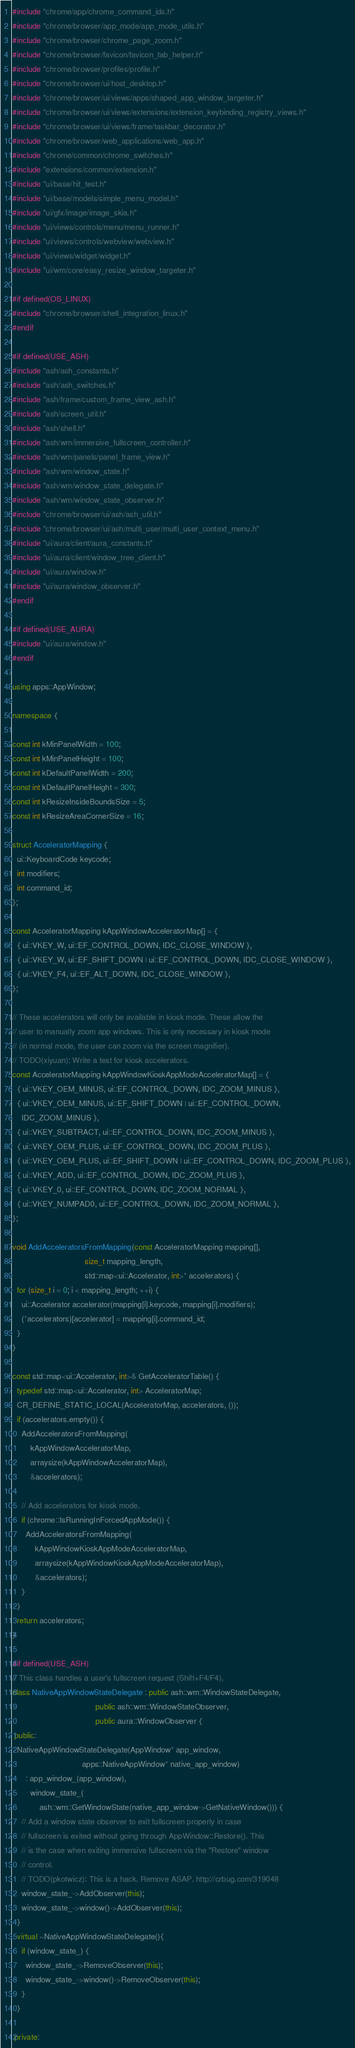Convert code to text. <code><loc_0><loc_0><loc_500><loc_500><_C++_>#include "chrome/app/chrome_command_ids.h"
#include "chrome/browser/app_mode/app_mode_utils.h"
#include "chrome/browser/chrome_page_zoom.h"
#include "chrome/browser/favicon/favicon_tab_helper.h"
#include "chrome/browser/profiles/profile.h"
#include "chrome/browser/ui/host_desktop.h"
#include "chrome/browser/ui/views/apps/shaped_app_window_targeter.h"
#include "chrome/browser/ui/views/extensions/extension_keybinding_registry_views.h"
#include "chrome/browser/ui/views/frame/taskbar_decorator.h"
#include "chrome/browser/web_applications/web_app.h"
#include "chrome/common/chrome_switches.h"
#include "extensions/common/extension.h"
#include "ui/base/hit_test.h"
#include "ui/base/models/simple_menu_model.h"
#include "ui/gfx/image/image_skia.h"
#include "ui/views/controls/menu/menu_runner.h"
#include "ui/views/controls/webview/webview.h"
#include "ui/views/widget/widget.h"
#include "ui/wm/core/easy_resize_window_targeter.h"

#if defined(OS_LINUX)
#include "chrome/browser/shell_integration_linux.h"
#endif

#if defined(USE_ASH)
#include "ash/ash_constants.h"
#include "ash/ash_switches.h"
#include "ash/frame/custom_frame_view_ash.h"
#include "ash/screen_util.h"
#include "ash/shell.h"
#include "ash/wm/immersive_fullscreen_controller.h"
#include "ash/wm/panels/panel_frame_view.h"
#include "ash/wm/window_state.h"
#include "ash/wm/window_state_delegate.h"
#include "ash/wm/window_state_observer.h"
#include "chrome/browser/ui/ash/ash_util.h"
#include "chrome/browser/ui/ash/multi_user/multi_user_context_menu.h"
#include "ui/aura/client/aura_constants.h"
#include "ui/aura/client/window_tree_client.h"
#include "ui/aura/window.h"
#include "ui/aura/window_observer.h"
#endif

#if defined(USE_AURA)
#include "ui/aura/window.h"
#endif

using apps::AppWindow;

namespace {

const int kMinPanelWidth = 100;
const int kMinPanelHeight = 100;
const int kDefaultPanelWidth = 200;
const int kDefaultPanelHeight = 300;
const int kResizeInsideBoundsSize = 5;
const int kResizeAreaCornerSize = 16;

struct AcceleratorMapping {
  ui::KeyboardCode keycode;
  int modifiers;
  int command_id;
};

const AcceleratorMapping kAppWindowAcceleratorMap[] = {
  { ui::VKEY_W, ui::EF_CONTROL_DOWN, IDC_CLOSE_WINDOW },
  { ui::VKEY_W, ui::EF_SHIFT_DOWN | ui::EF_CONTROL_DOWN, IDC_CLOSE_WINDOW },
  { ui::VKEY_F4, ui::EF_ALT_DOWN, IDC_CLOSE_WINDOW },
};

// These accelerators will only be available in kiosk mode. These allow the
// user to manually zoom app windows. This is only necessary in kiosk mode
// (in normal mode, the user can zoom via the screen magnifier).
// TODO(xiyuan): Write a test for kiosk accelerators.
const AcceleratorMapping kAppWindowKioskAppModeAcceleratorMap[] = {
  { ui::VKEY_OEM_MINUS, ui::EF_CONTROL_DOWN, IDC_ZOOM_MINUS },
  { ui::VKEY_OEM_MINUS, ui::EF_SHIFT_DOWN | ui::EF_CONTROL_DOWN,
    IDC_ZOOM_MINUS },
  { ui::VKEY_SUBTRACT, ui::EF_CONTROL_DOWN, IDC_ZOOM_MINUS },
  { ui::VKEY_OEM_PLUS, ui::EF_CONTROL_DOWN, IDC_ZOOM_PLUS },
  { ui::VKEY_OEM_PLUS, ui::EF_SHIFT_DOWN | ui::EF_CONTROL_DOWN, IDC_ZOOM_PLUS },
  { ui::VKEY_ADD, ui::EF_CONTROL_DOWN, IDC_ZOOM_PLUS },
  { ui::VKEY_0, ui::EF_CONTROL_DOWN, IDC_ZOOM_NORMAL },
  { ui::VKEY_NUMPAD0, ui::EF_CONTROL_DOWN, IDC_ZOOM_NORMAL },
};

void AddAcceleratorsFromMapping(const AcceleratorMapping mapping[],
                                size_t mapping_length,
                                std::map<ui::Accelerator, int>* accelerators) {
  for (size_t i = 0; i < mapping_length; ++i) {
    ui::Accelerator accelerator(mapping[i].keycode, mapping[i].modifiers);
    (*accelerators)[accelerator] = mapping[i].command_id;
  }
}

const std::map<ui::Accelerator, int>& GetAcceleratorTable() {
  typedef std::map<ui::Accelerator, int> AcceleratorMap;
  CR_DEFINE_STATIC_LOCAL(AcceleratorMap, accelerators, ());
  if (accelerators.empty()) {
    AddAcceleratorsFromMapping(
        kAppWindowAcceleratorMap,
        arraysize(kAppWindowAcceleratorMap),
        &accelerators);

    // Add accelerators for kiosk mode.
    if (chrome::IsRunningInForcedAppMode()) {
      AddAcceleratorsFromMapping(
          kAppWindowKioskAppModeAcceleratorMap,
          arraysize(kAppWindowKioskAppModeAcceleratorMap),
          &accelerators);
    }
  }
  return accelerators;
}

#if defined(USE_ASH)
// This class handles a user's fullscreen request (Shift+F4/F4).
class NativeAppWindowStateDelegate : public ash::wm::WindowStateDelegate,
                                     public ash::wm::WindowStateObserver,
                                     public aura::WindowObserver {
 public:
  NativeAppWindowStateDelegate(AppWindow* app_window,
                               apps::NativeAppWindow* native_app_window)
      : app_window_(app_window),
        window_state_(
            ash::wm::GetWindowState(native_app_window->GetNativeWindow())) {
    // Add a window state observer to exit fullscreen properly in case
    // fullscreen is exited without going through AppWindow::Restore(). This
    // is the case when exiting immersive fullscreen via the "Restore" window
    // control.
    // TODO(pkotwicz): This is a hack. Remove ASAP. http://crbug.com/319048
    window_state_->AddObserver(this);
    window_state_->window()->AddObserver(this);
  }
  virtual ~NativeAppWindowStateDelegate(){
    if (window_state_) {
      window_state_->RemoveObserver(this);
      window_state_->window()->RemoveObserver(this);
    }
  }

 private:</code> 